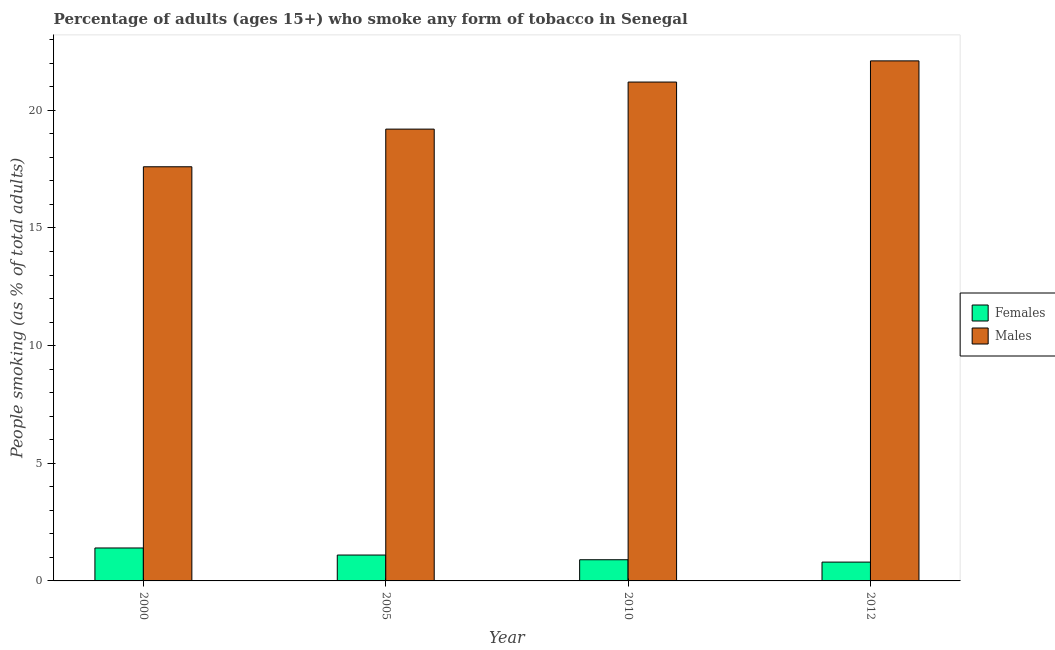How many different coloured bars are there?
Provide a short and direct response. 2. What is the label of the 3rd group of bars from the left?
Provide a short and direct response. 2010. In how many cases, is the number of bars for a given year not equal to the number of legend labels?
Offer a terse response. 0. What is the percentage of males who smoke in 2005?
Give a very brief answer. 19.2. Across all years, what is the maximum percentage of females who smoke?
Keep it short and to the point. 1.4. In which year was the percentage of females who smoke maximum?
Your answer should be compact. 2000. In which year was the percentage of females who smoke minimum?
Provide a succinct answer. 2012. What is the total percentage of males who smoke in the graph?
Give a very brief answer. 80.1. What is the difference between the percentage of males who smoke in 2005 and that in 2010?
Offer a terse response. -2. What is the difference between the percentage of males who smoke in 2005 and the percentage of females who smoke in 2012?
Ensure brevity in your answer.  -2.9. What is the average percentage of males who smoke per year?
Provide a succinct answer. 20.02. In the year 2005, what is the difference between the percentage of females who smoke and percentage of males who smoke?
Your answer should be very brief. 0. In how many years, is the percentage of males who smoke greater than 16 %?
Give a very brief answer. 4. What is the ratio of the percentage of males who smoke in 2000 to that in 2010?
Provide a short and direct response. 0.83. Is the percentage of males who smoke in 2000 less than that in 2010?
Your answer should be compact. Yes. What is the difference between the highest and the second highest percentage of males who smoke?
Your answer should be very brief. 0.9. What does the 2nd bar from the left in 2005 represents?
Give a very brief answer. Males. What does the 1st bar from the right in 2000 represents?
Ensure brevity in your answer.  Males. How many bars are there?
Make the answer very short. 8. Are all the bars in the graph horizontal?
Make the answer very short. No. How many years are there in the graph?
Provide a succinct answer. 4. What is the difference between two consecutive major ticks on the Y-axis?
Keep it short and to the point. 5. How are the legend labels stacked?
Your answer should be compact. Vertical. What is the title of the graph?
Give a very brief answer. Percentage of adults (ages 15+) who smoke any form of tobacco in Senegal. Does "Researchers" appear as one of the legend labels in the graph?
Make the answer very short. No. What is the label or title of the X-axis?
Keep it short and to the point. Year. What is the label or title of the Y-axis?
Offer a very short reply. People smoking (as % of total adults). What is the People smoking (as % of total adults) in Females in 2000?
Offer a terse response. 1.4. What is the People smoking (as % of total adults) of Females in 2005?
Give a very brief answer. 1.1. What is the People smoking (as % of total adults) of Males in 2010?
Offer a very short reply. 21.2. What is the People smoking (as % of total adults) of Males in 2012?
Your response must be concise. 22.1. Across all years, what is the maximum People smoking (as % of total adults) of Females?
Keep it short and to the point. 1.4. Across all years, what is the maximum People smoking (as % of total adults) in Males?
Ensure brevity in your answer.  22.1. Across all years, what is the minimum People smoking (as % of total adults) in Females?
Your answer should be very brief. 0.8. Across all years, what is the minimum People smoking (as % of total adults) in Males?
Your response must be concise. 17.6. What is the total People smoking (as % of total adults) of Females in the graph?
Keep it short and to the point. 4.2. What is the total People smoking (as % of total adults) in Males in the graph?
Ensure brevity in your answer.  80.1. What is the difference between the People smoking (as % of total adults) of Males in 2000 and that in 2005?
Keep it short and to the point. -1.6. What is the difference between the People smoking (as % of total adults) in Females in 2000 and that in 2010?
Make the answer very short. 0.5. What is the difference between the People smoking (as % of total adults) in Males in 2000 and that in 2010?
Provide a succinct answer. -3.6. What is the difference between the People smoking (as % of total adults) in Females in 2000 and that in 2012?
Your answer should be compact. 0.6. What is the difference between the People smoking (as % of total adults) of Males in 2000 and that in 2012?
Ensure brevity in your answer.  -4.5. What is the difference between the People smoking (as % of total adults) in Females in 2010 and that in 2012?
Keep it short and to the point. 0.1. What is the difference between the People smoking (as % of total adults) of Males in 2010 and that in 2012?
Make the answer very short. -0.9. What is the difference between the People smoking (as % of total adults) of Females in 2000 and the People smoking (as % of total adults) of Males in 2005?
Give a very brief answer. -17.8. What is the difference between the People smoking (as % of total adults) of Females in 2000 and the People smoking (as % of total adults) of Males in 2010?
Your answer should be very brief. -19.8. What is the difference between the People smoking (as % of total adults) in Females in 2000 and the People smoking (as % of total adults) in Males in 2012?
Your answer should be compact. -20.7. What is the difference between the People smoking (as % of total adults) of Females in 2005 and the People smoking (as % of total adults) of Males in 2010?
Give a very brief answer. -20.1. What is the difference between the People smoking (as % of total adults) in Females in 2005 and the People smoking (as % of total adults) in Males in 2012?
Keep it short and to the point. -21. What is the difference between the People smoking (as % of total adults) of Females in 2010 and the People smoking (as % of total adults) of Males in 2012?
Provide a short and direct response. -21.2. What is the average People smoking (as % of total adults) in Males per year?
Offer a terse response. 20.02. In the year 2000, what is the difference between the People smoking (as % of total adults) in Females and People smoking (as % of total adults) in Males?
Offer a very short reply. -16.2. In the year 2005, what is the difference between the People smoking (as % of total adults) in Females and People smoking (as % of total adults) in Males?
Your answer should be compact. -18.1. In the year 2010, what is the difference between the People smoking (as % of total adults) in Females and People smoking (as % of total adults) in Males?
Make the answer very short. -20.3. In the year 2012, what is the difference between the People smoking (as % of total adults) in Females and People smoking (as % of total adults) in Males?
Your response must be concise. -21.3. What is the ratio of the People smoking (as % of total adults) in Females in 2000 to that in 2005?
Provide a short and direct response. 1.27. What is the ratio of the People smoking (as % of total adults) of Females in 2000 to that in 2010?
Make the answer very short. 1.56. What is the ratio of the People smoking (as % of total adults) in Males in 2000 to that in 2010?
Provide a succinct answer. 0.83. What is the ratio of the People smoking (as % of total adults) in Males in 2000 to that in 2012?
Provide a succinct answer. 0.8. What is the ratio of the People smoking (as % of total adults) of Females in 2005 to that in 2010?
Your answer should be very brief. 1.22. What is the ratio of the People smoking (as % of total adults) in Males in 2005 to that in 2010?
Give a very brief answer. 0.91. What is the ratio of the People smoking (as % of total adults) in Females in 2005 to that in 2012?
Offer a very short reply. 1.38. What is the ratio of the People smoking (as % of total adults) of Males in 2005 to that in 2012?
Ensure brevity in your answer.  0.87. What is the ratio of the People smoking (as % of total adults) of Males in 2010 to that in 2012?
Your response must be concise. 0.96. What is the difference between the highest and the second highest People smoking (as % of total adults) in Females?
Ensure brevity in your answer.  0.3. What is the difference between the highest and the second highest People smoking (as % of total adults) in Males?
Keep it short and to the point. 0.9. What is the difference between the highest and the lowest People smoking (as % of total adults) of Females?
Make the answer very short. 0.6. 